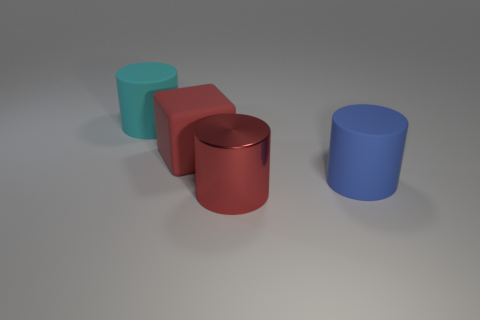Add 4 tiny green metal objects. How many objects exist? 8 Subtract all big matte cylinders. How many cylinders are left? 1 Subtract 1 blocks. How many blocks are left? 0 Subtract all red cylinders. How many cylinders are left? 2 Subtract all cubes. How many objects are left? 3 Subtract 0 brown cylinders. How many objects are left? 4 Subtract all purple blocks. Subtract all yellow cylinders. How many blocks are left? 1 Subtract all big blue cylinders. Subtract all large blue rubber cylinders. How many objects are left? 2 Add 2 cyan objects. How many cyan objects are left? 3 Add 1 yellow balls. How many yellow balls exist? 1 